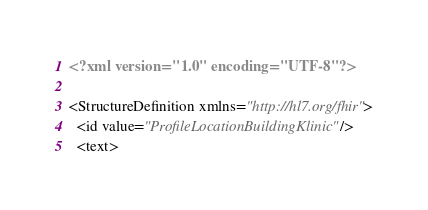<code> <loc_0><loc_0><loc_500><loc_500><_XML_><?xml version="1.0" encoding="UTF-8"?>

<StructureDefinition xmlns="http://hl7.org/fhir">
  <id value="ProfileLocationBuildingKlinic"/>
  <text></code> 